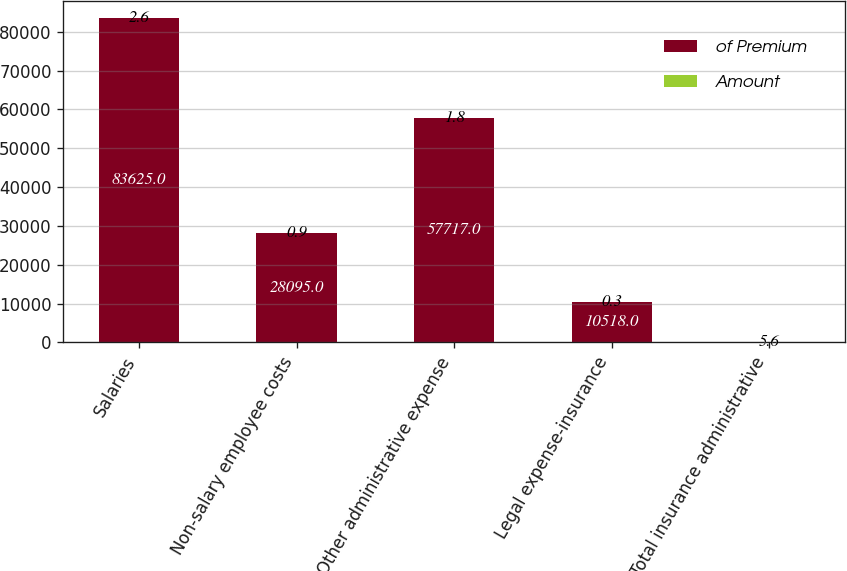Convert chart to OTSL. <chart><loc_0><loc_0><loc_500><loc_500><stacked_bar_chart><ecel><fcel>Salaries<fcel>Non-salary employee costs<fcel>Other administrative expense<fcel>Legal expense-insurance<fcel>Total insurance administrative<nl><fcel>of Premium<fcel>83625<fcel>28095<fcel>57717<fcel>10518<fcel>5.6<nl><fcel>Amount<fcel>2.6<fcel>0.9<fcel>1.8<fcel>0.3<fcel>5.6<nl></chart> 